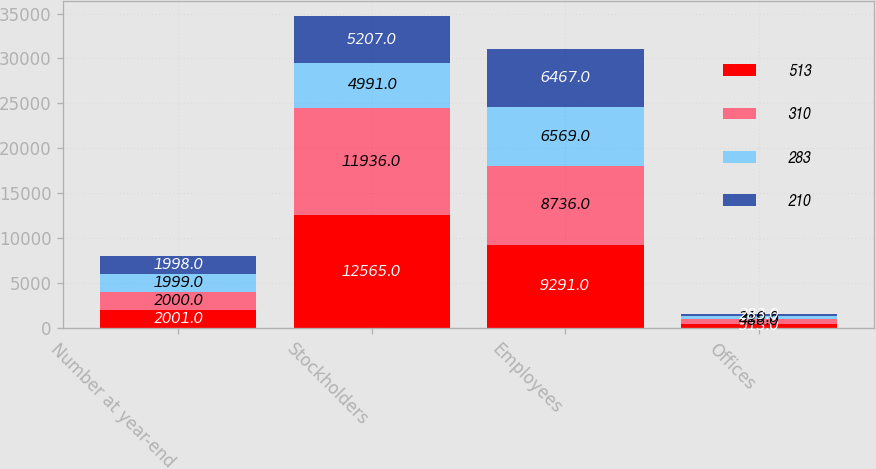Convert chart. <chart><loc_0><loc_0><loc_500><loc_500><stacked_bar_chart><ecel><fcel>Number at year-end<fcel>Stockholders<fcel>Employees<fcel>Offices<nl><fcel>513<fcel>2001<fcel>12565<fcel>9291<fcel>513<nl><fcel>310<fcel>2000<fcel>11936<fcel>8736<fcel>488<nl><fcel>283<fcel>1999<fcel>4991<fcel>6569<fcel>310<nl><fcel>210<fcel>1998<fcel>5207<fcel>6467<fcel>283<nl></chart> 